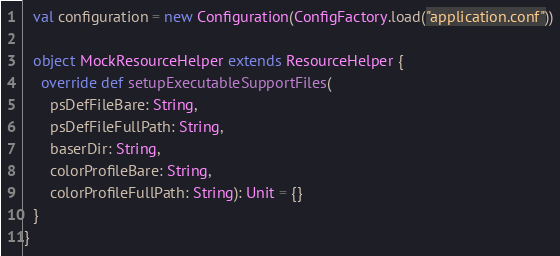<code> <loc_0><loc_0><loc_500><loc_500><_Scala_>  val configuration = new Configuration(ConfigFactory.load("application.conf"))

  object MockResourceHelper extends ResourceHelper {
    override def setupExecutableSupportFiles(
      psDefFileBare: String,
      psDefFileFullPath: String,
      baserDir: String,
      colorProfileBare: String,
      colorProfileFullPath: String): Unit = {}
  }
}
</code> 